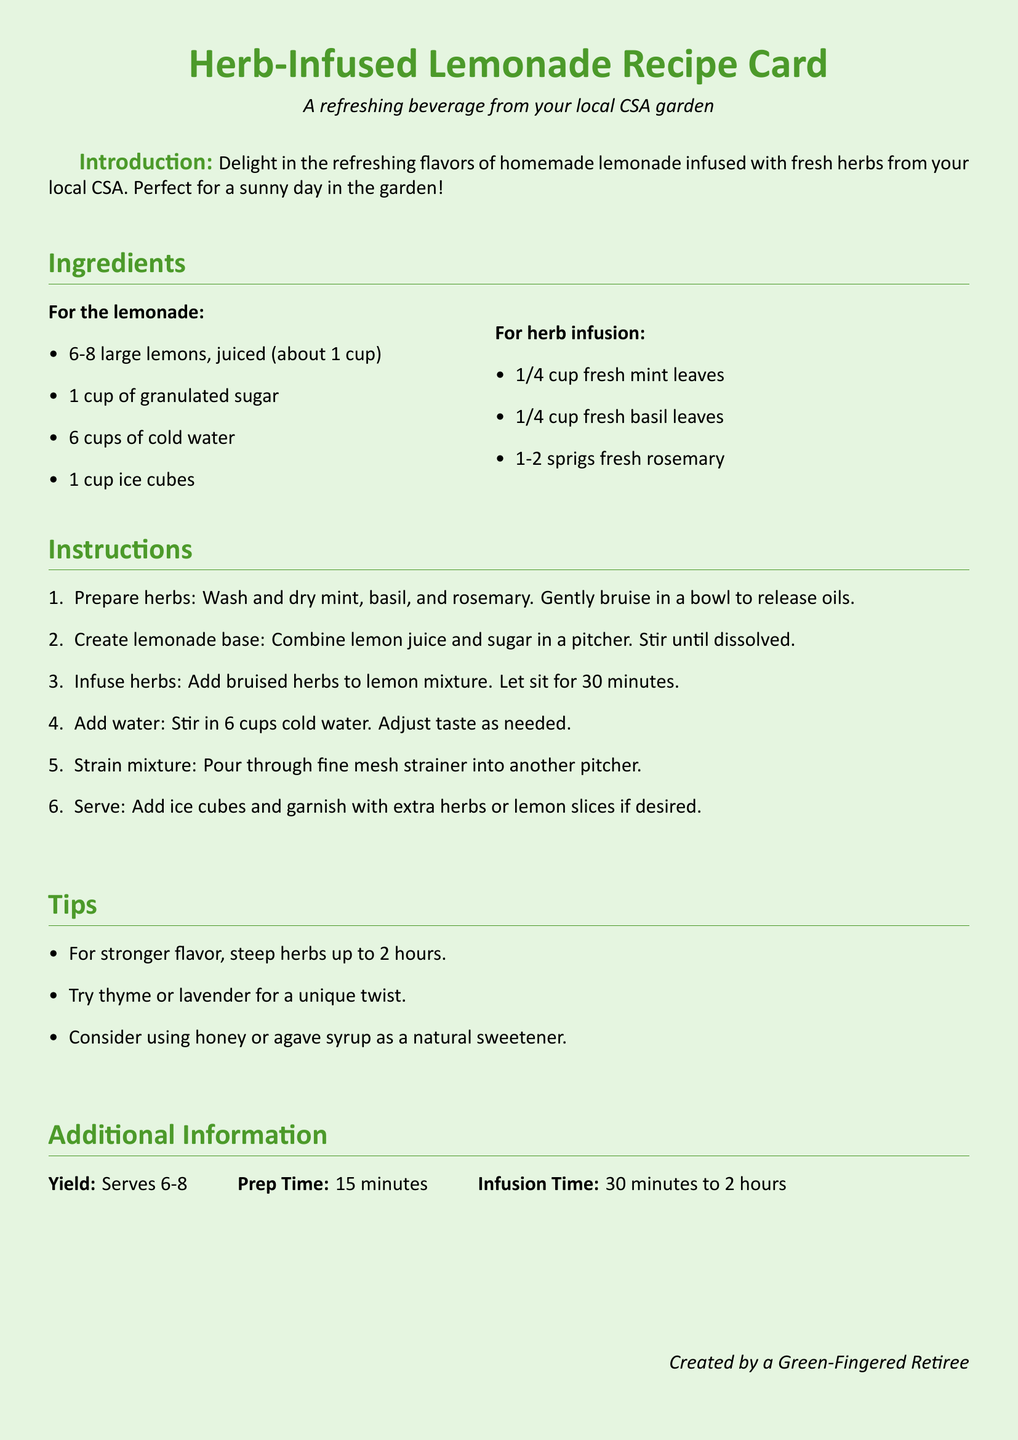What are the main herbs used in this recipe? The main herbs listed in the recipe are mint, basil, and rosemary.
Answer: mint, basil, rosemary How many cups of water are needed for the lemonade? The recipe specifies that 6 cups of cold water are required.
Answer: 6 cups What is the total prep time for the recipe? The document indicates that the prep time is 15 minutes.
Answer: 15 minutes How long should the herbs infuse in the lemonade mixture? The infusion time can range from 30 minutes to 2 hours, as stated in the tips.
Answer: 30 minutes to 2 hours How many servings does the recipe yield? The yield of the recipe is mentioned as serving 6-8 people.
Answer: 6-8 What is the first step in the instructions? The first step involves washing and drying the mint, basil, and rosemary, and then bruising them in a bowl.
Answer: Prepare herbs What is an alternative sweetener suggested in the tips? The recipe suggests honey or agave syrup as a natural sweetener alternative.
Answer: honey or agave syrup Which herb can be used for a unique twist according to the tips? The document mentions that thyme or lavender can be used for a unique twist.
Answer: thyme or lavender 